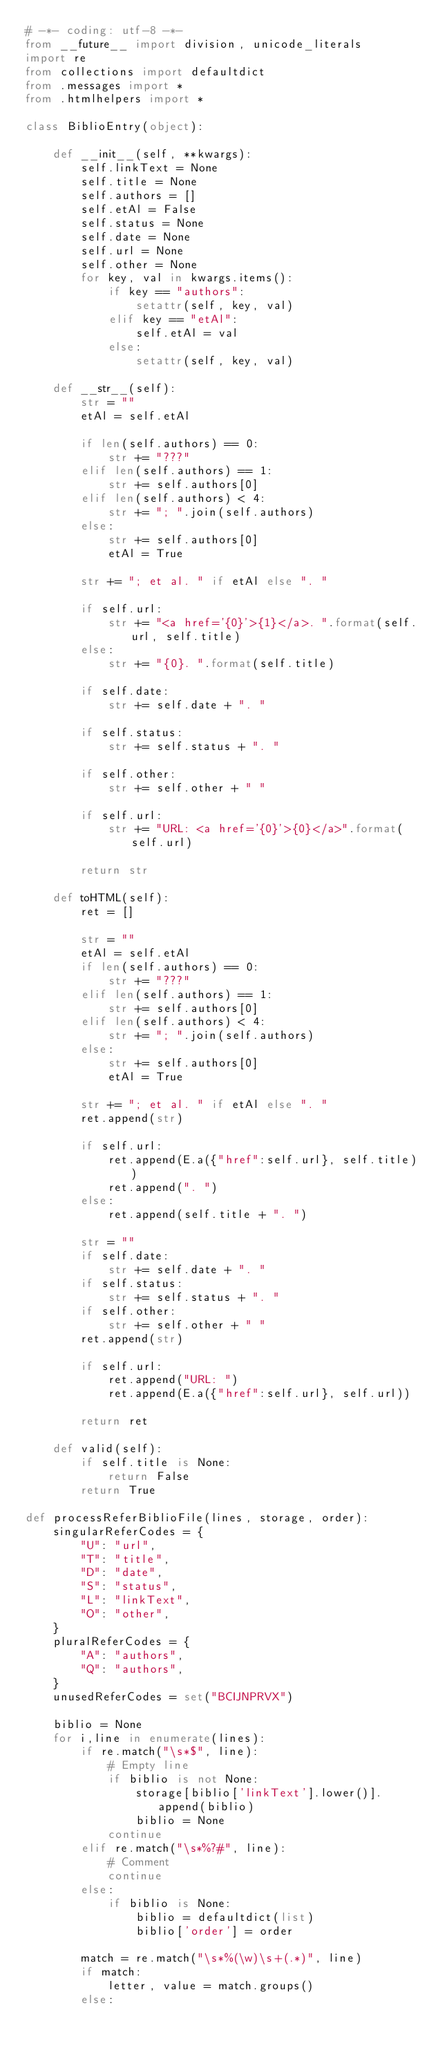<code> <loc_0><loc_0><loc_500><loc_500><_Python_># -*- coding: utf-8 -*-
from __future__ import division, unicode_literals
import re
from collections import defaultdict
from .messages import *
from .htmlhelpers import *

class BiblioEntry(object):

    def __init__(self, **kwargs):
        self.linkText = None
        self.title = None
        self.authors = []
        self.etAl = False
        self.status = None
        self.date = None
        self.url = None
        self.other = None
        for key, val in kwargs.items():
            if key == "authors":
                setattr(self, key, val)
            elif key == "etAl":
                self.etAl = val
            else:
                setattr(self, key, val)

    def __str__(self):
        str = ""
        etAl = self.etAl

        if len(self.authors) == 0:
            str += "???"
        elif len(self.authors) == 1:
            str += self.authors[0]
        elif len(self.authors) < 4:
            str += "; ".join(self.authors)
        else:
            str += self.authors[0]
            etAl = True

        str += "; et al. " if etAl else ". "

        if self.url:
            str += "<a href='{0}'>{1}</a>. ".format(self.url, self.title)
        else:
            str += "{0}. ".format(self.title)

        if self.date:
            str += self.date + ". "

        if self.status:
            str += self.status + ". "

        if self.other:
            str += self.other + " "

        if self.url:
            str += "URL: <a href='{0}'>{0}</a>".format(self.url)

        return str

    def toHTML(self):
        ret = []

        str = ""
        etAl = self.etAl
        if len(self.authors) == 0:
            str += "???"
        elif len(self.authors) == 1:
            str += self.authors[0]
        elif len(self.authors) < 4:
            str += "; ".join(self.authors)
        else:
            str += self.authors[0]
            etAl = True

        str += "; et al. " if etAl else ". "
        ret.append(str)

        if self.url:
            ret.append(E.a({"href":self.url}, self.title))
            ret.append(". ")
        else:
            ret.append(self.title + ". ")

        str = ""
        if self.date:
            str += self.date + ". "
        if self.status:
            str += self.status + ". "
        if self.other:
            str += self.other + " "
        ret.append(str)

        if self.url:
            ret.append("URL: ")
            ret.append(E.a({"href":self.url}, self.url))

        return ret

    def valid(self):
        if self.title is None:
            return False
        return True

def processReferBiblioFile(lines, storage, order):
    singularReferCodes = {
        "U": "url",
        "T": "title",
        "D": "date",
        "S": "status",
        "L": "linkText",
        "O": "other",
    }
    pluralReferCodes = {
        "A": "authors",
        "Q": "authors",
    }
    unusedReferCodes = set("BCIJNPRVX")

    biblio = None
    for i,line in enumerate(lines):
        if re.match("\s*$", line):
            # Empty line
            if biblio is not None:
                storage[biblio['linkText'].lower()].append(biblio)
                biblio = None
            continue
        elif re.match("\s*%?#", line):
            # Comment
            continue
        else:
            if biblio is None:
                biblio = defaultdict(list)
                biblio['order'] = order

        match = re.match("\s*%(\w)\s+(.*)", line)
        if match:
            letter, value = match.groups()
        else:</code> 